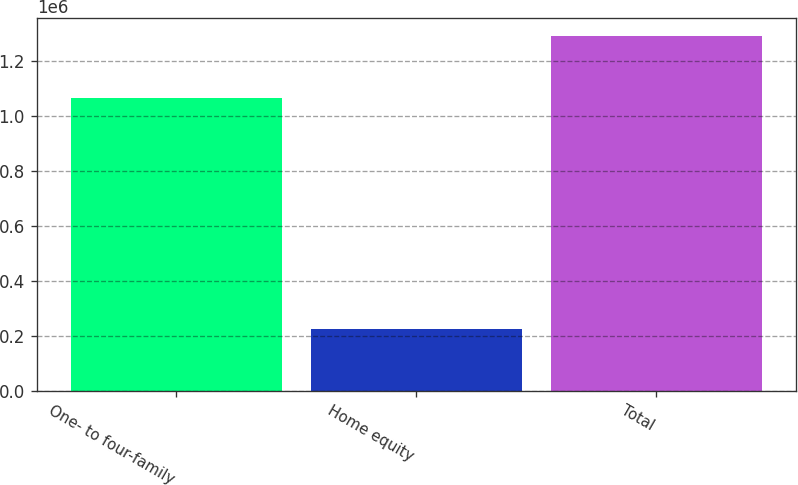Convert chart. <chart><loc_0><loc_0><loc_500><loc_500><bar_chart><fcel>One- to four-family<fcel>Home equity<fcel>Total<nl><fcel>1.06617e+06<fcel>223419<fcel>1.28959e+06<nl></chart> 